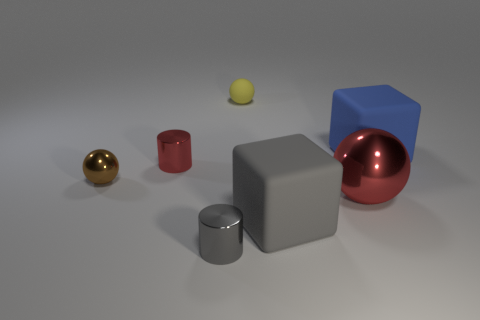What number of red things are metallic things or rubber things?
Give a very brief answer. 2. What number of gray blocks are the same size as the blue rubber block?
Provide a short and direct response. 1. Do the red thing that is to the right of the tiny matte ball and the small red thing have the same material?
Provide a short and direct response. Yes. There is a large matte cube that is in front of the blue block; are there any gray shiny cylinders that are behind it?
Offer a terse response. No. There is a big red object that is the same shape as the tiny yellow thing; what is it made of?
Ensure brevity in your answer.  Metal. Are there more small yellow matte balls that are in front of the small yellow ball than big matte blocks that are on the right side of the blue matte cube?
Offer a very short reply. No. What shape is the gray object that is the same material as the brown ball?
Make the answer very short. Cylinder. Are there more big things that are behind the tiny red object than tiny balls?
Your response must be concise. No. How many tiny objects are the same color as the large ball?
Ensure brevity in your answer.  1. How many other objects are the same color as the big shiny ball?
Provide a succinct answer. 1. 